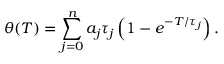Convert formula to latex. <formula><loc_0><loc_0><loc_500><loc_500>\theta ( T ) = \sum _ { j = 0 } ^ { n } a _ { j } \tau _ { j } \left ( 1 - e ^ { - T / \tau _ { j } } \right ) .</formula> 